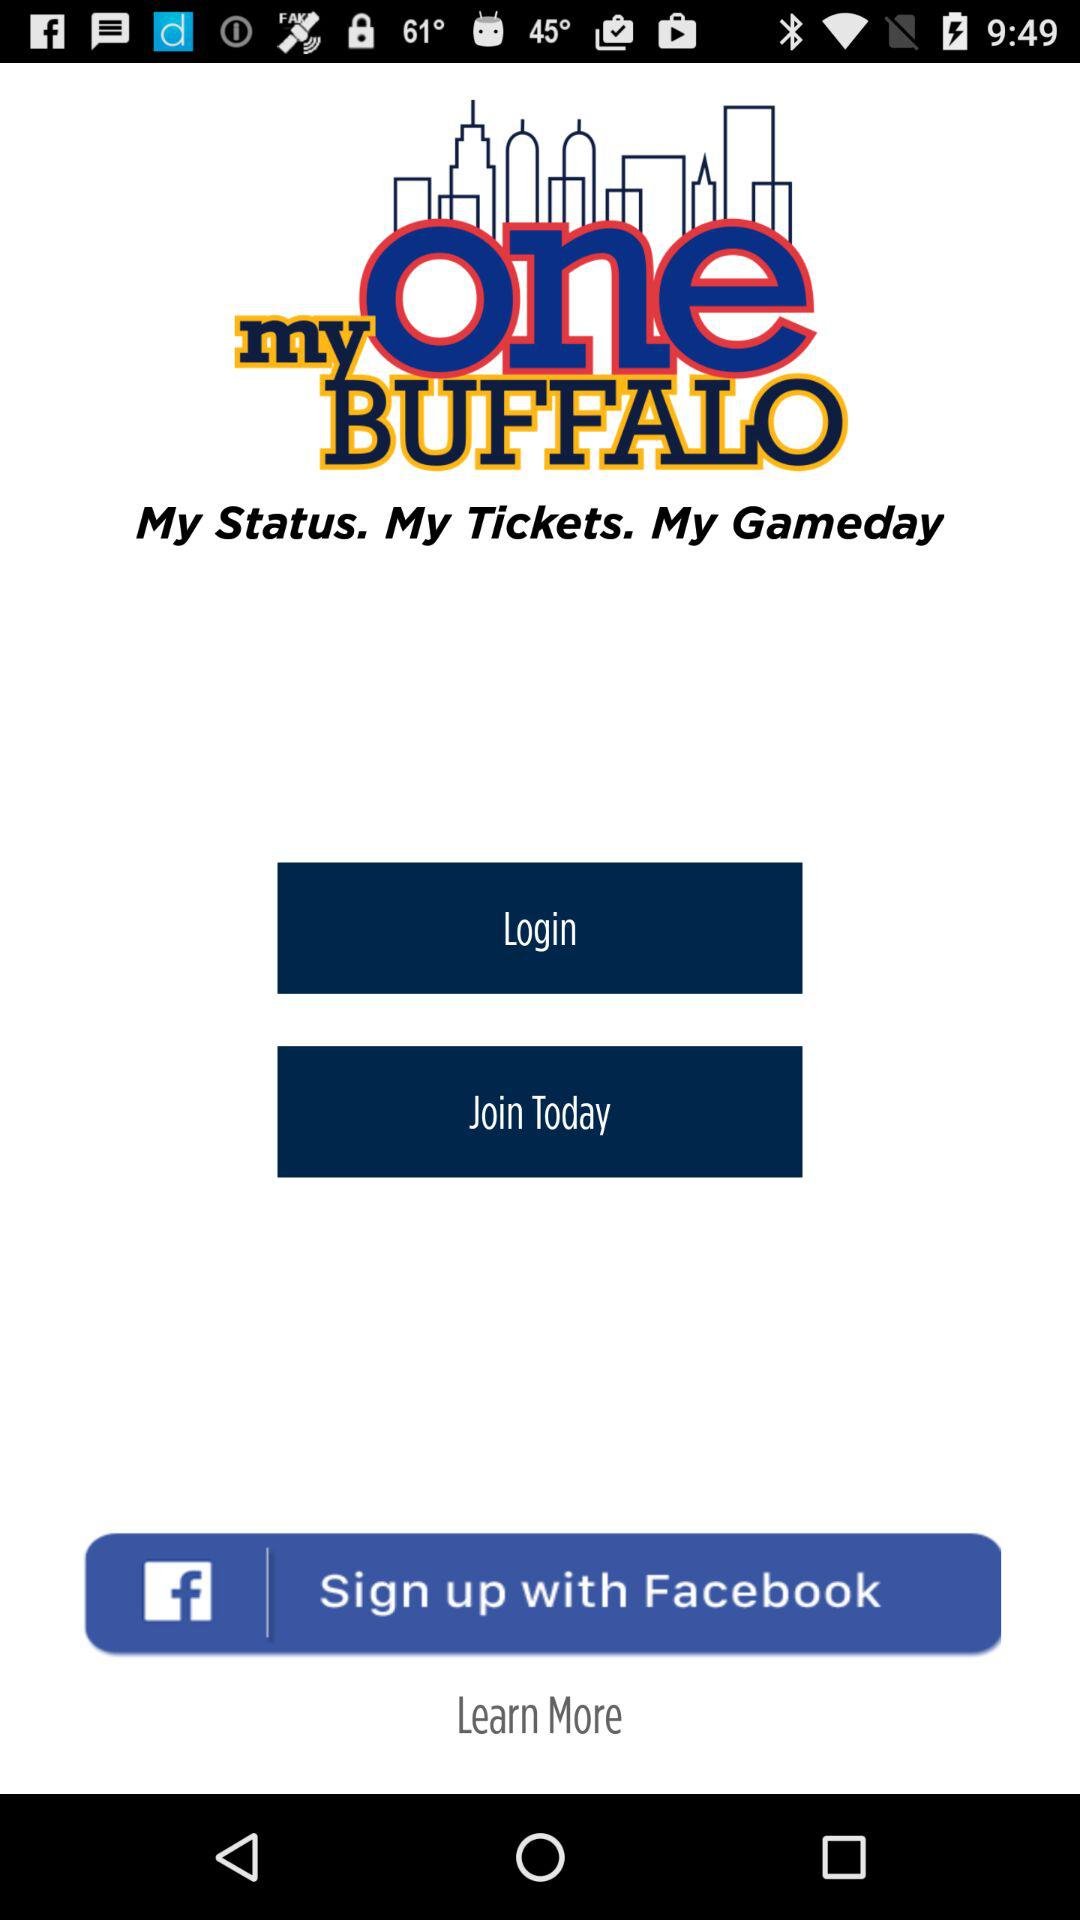What is the app title? The app title is "my one BUFFALO". 